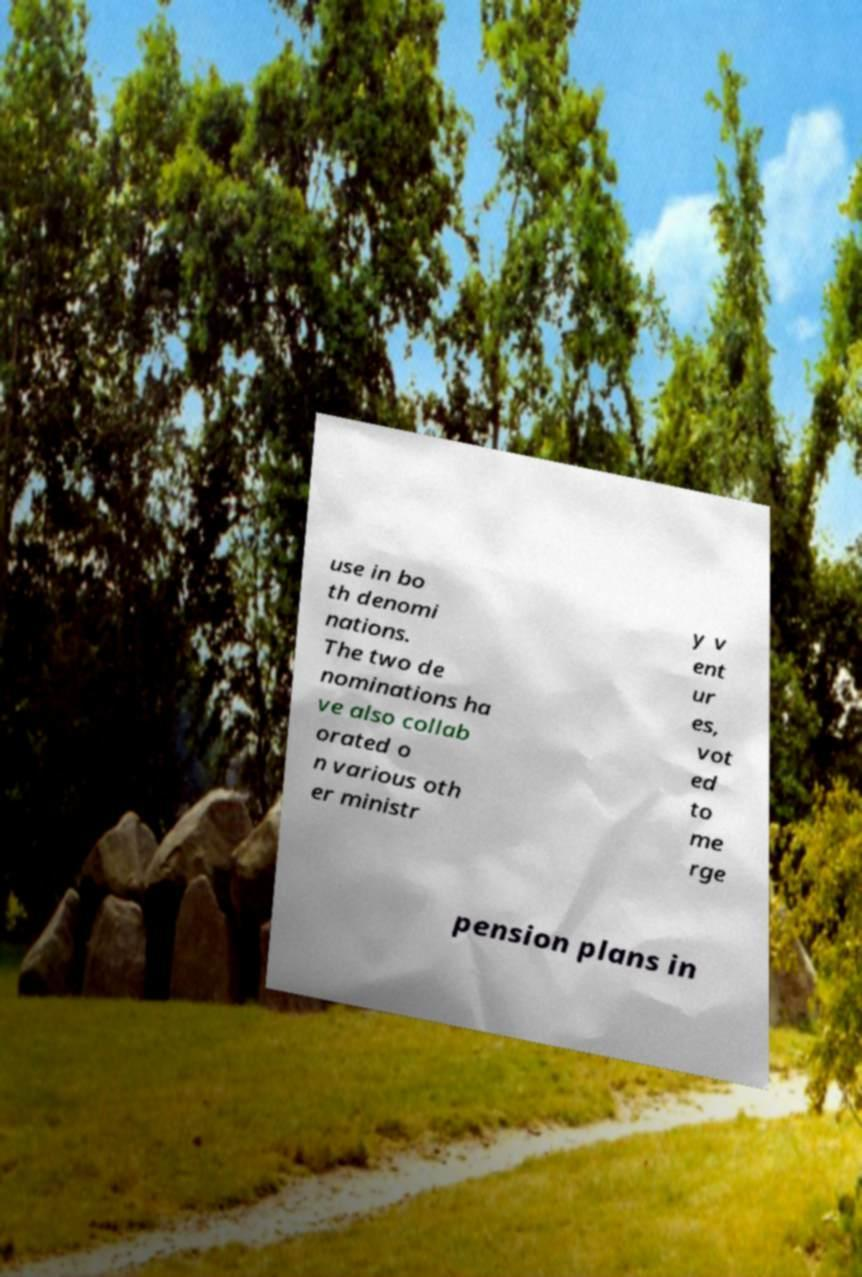Please read and relay the text visible in this image. What does it say? use in bo th denomi nations. The two de nominations ha ve also collab orated o n various oth er ministr y v ent ur es, vot ed to me rge pension plans in 